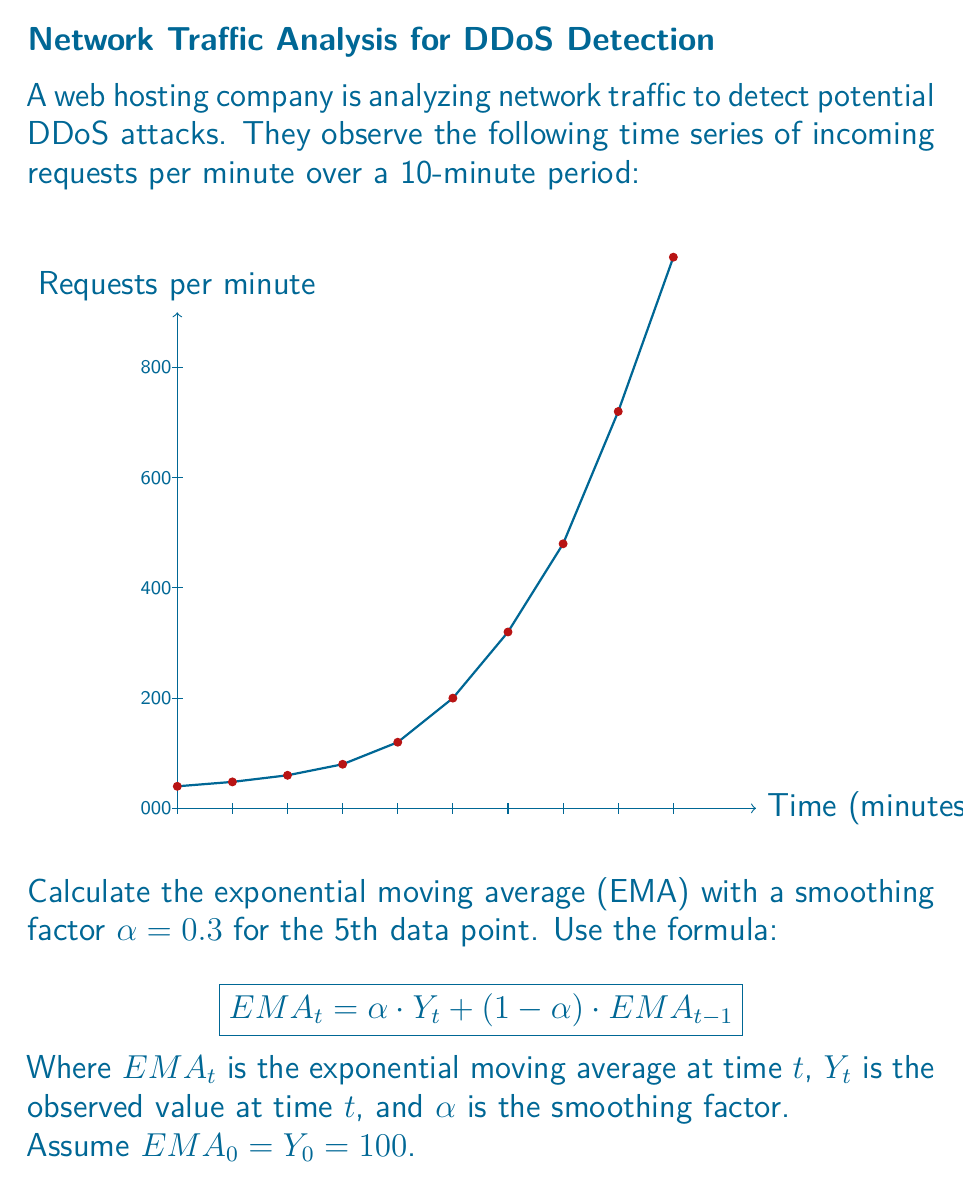Solve this math problem. To calculate the EMA for the 5th data point, we need to iteratively calculate the EMA for each preceding point:

1) For t = 1:
   $EMA_1 = 0.3 \cdot 120 + (1-0.3) \cdot 100 = 36 + 70 = 106$

2) For t = 2:
   $EMA_2 = 0.3 \cdot 150 + (1-0.3) \cdot 106 = 45 + 74.2 = 119.2$

3) For t = 3:
   $EMA_3 = 0.3 \cdot 200 + (1-0.3) \cdot 119.2 = 60 + 83.44 = 143.44$

4) For t = 4:
   $EMA_4 = 0.3 \cdot 300 + (1-0.3) \cdot 143.44 = 90 + 100.408 = 190.408$

5) Finally, for t = 5 (the 5th data point):
   $EMA_5 = 0.3 \cdot 500 + (1-0.3) \cdot 190.408 = 150 + 133.2856 = 283.2856$

Therefore, the EMA for the 5th data point is approximately 283.29.
Answer: 283.29 